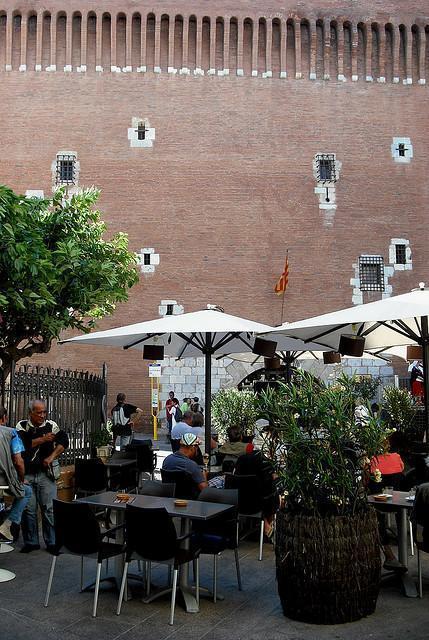Umbrellas provide what here?
Select the accurate response from the four choices given to answer the question.
Options: Shade, color, advertising, rain cover. Shade. 